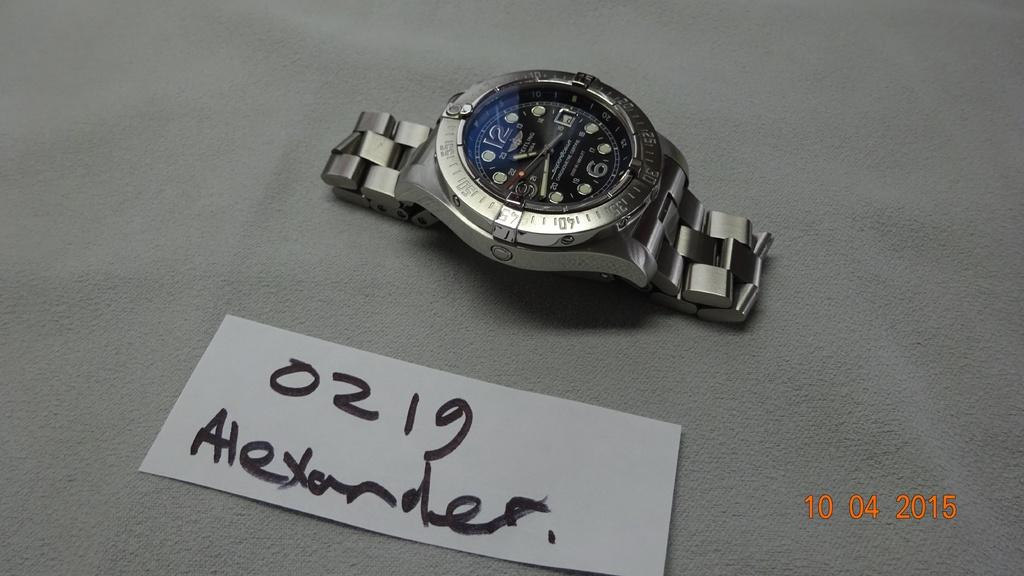<image>
Give a short and clear explanation of the subsequent image. A watch is on a grey background next to a sign that says 0219 Alexander. 